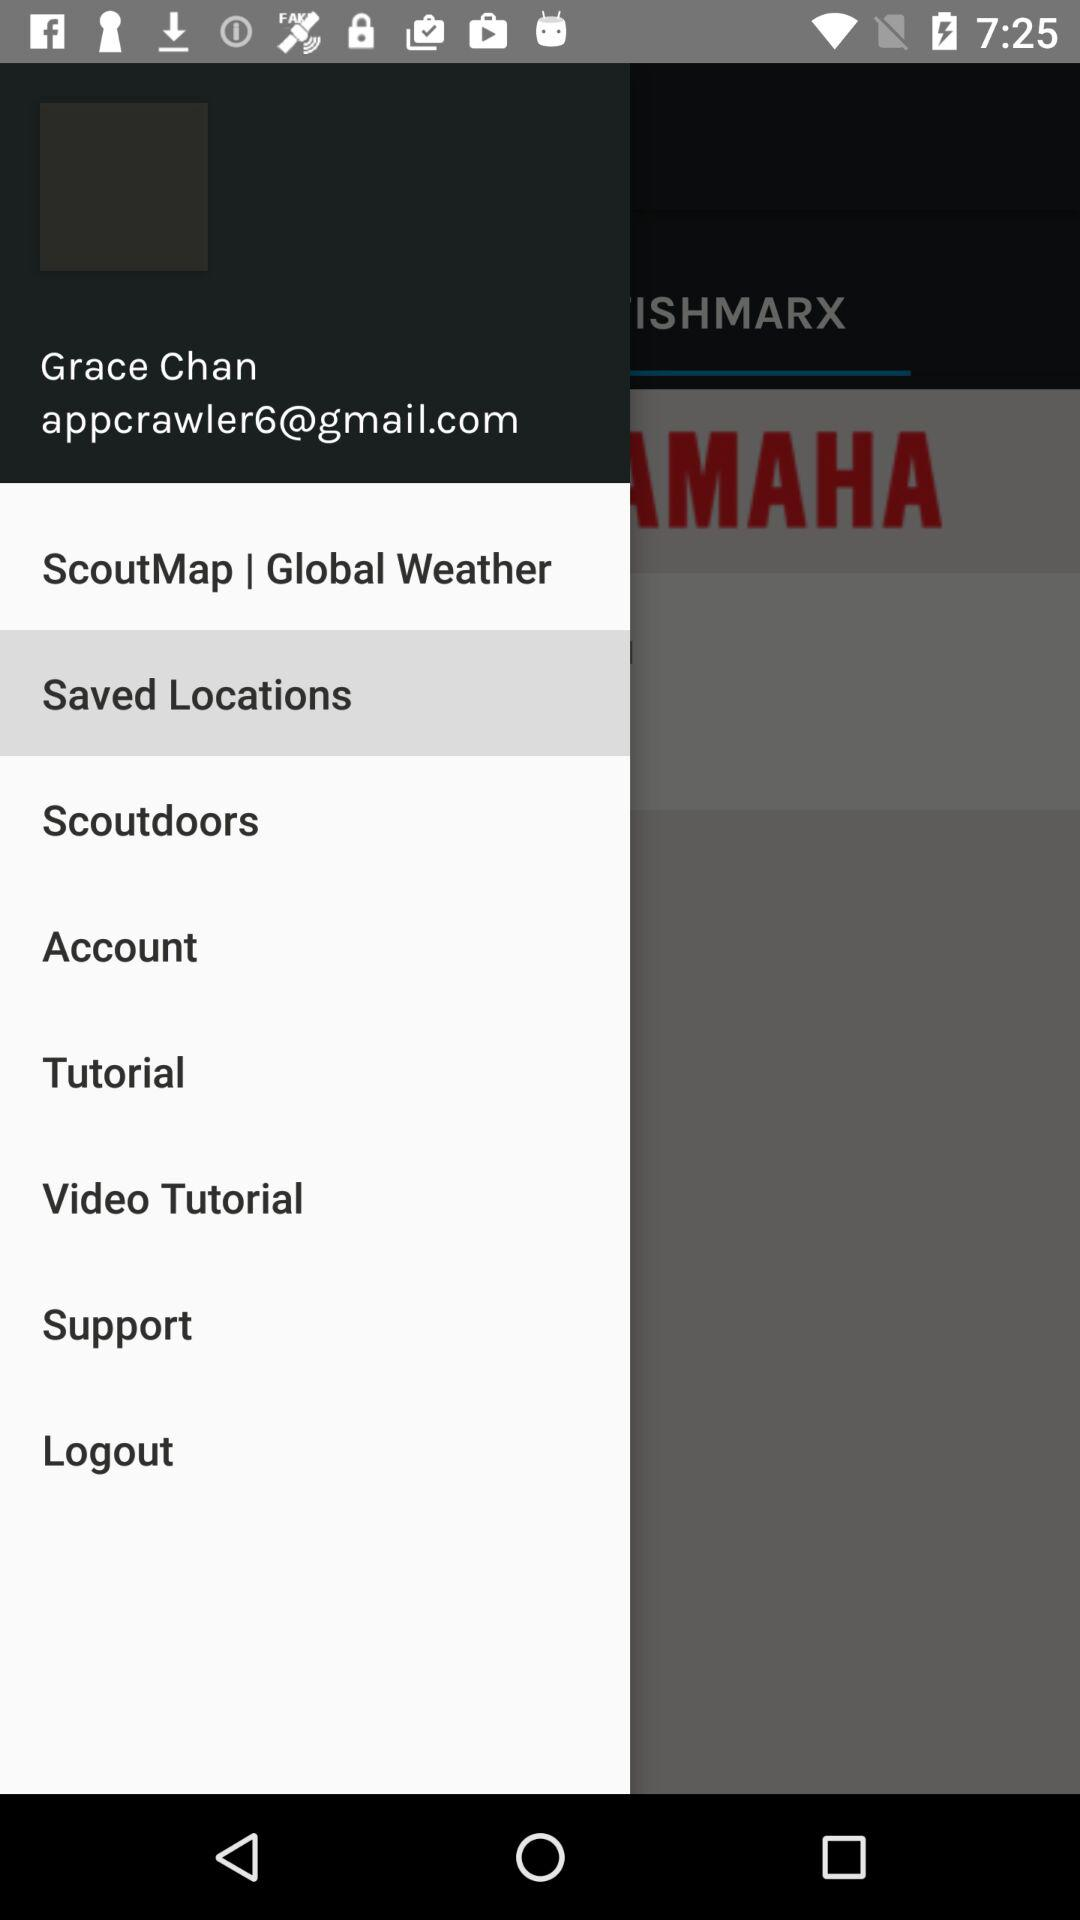Which library is selected? The selected library is "Saved Locations". 